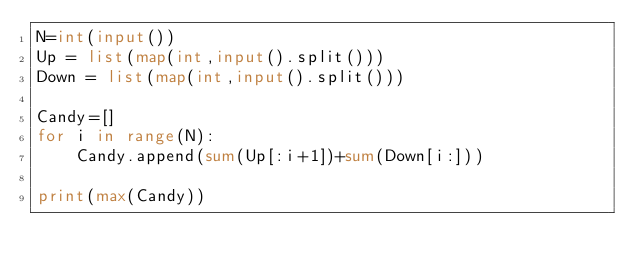<code> <loc_0><loc_0><loc_500><loc_500><_Python_>N=int(input())
Up = list(map(int,input().split()))
Down = list(map(int,input().split()))

Candy=[]
for i in range(N):
    Candy.append(sum(Up[:i+1])+sum(Down[i:]))

print(max(Candy))</code> 